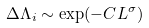<formula> <loc_0><loc_0><loc_500><loc_500>\Delta \Lambda _ { i } \sim \exp ( - C L ^ { \sigma } )</formula> 